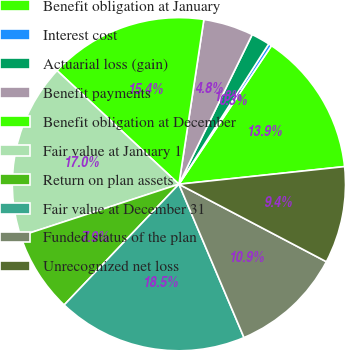Convert chart to OTSL. <chart><loc_0><loc_0><loc_500><loc_500><pie_chart><fcel>Benefit obligation at January<fcel>Interest cost<fcel>Actuarial loss (gain)<fcel>Benefit payments<fcel>Benefit obligation at December<fcel>Fair value at January 1<fcel>Return on plan assets<fcel>Fair value at December 31<fcel>Funded status of the plan<fcel>Unrecognized net loss<nl><fcel>13.94%<fcel>0.31%<fcel>1.82%<fcel>4.85%<fcel>15.45%<fcel>16.97%<fcel>7.88%<fcel>18.48%<fcel>10.91%<fcel>9.39%<nl></chart> 